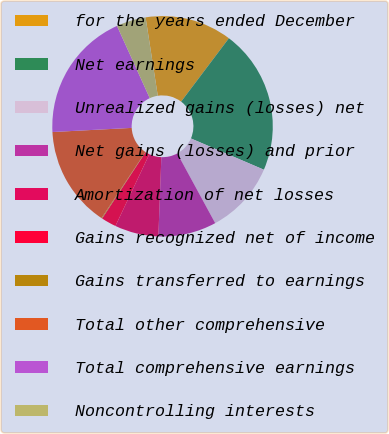Convert chart. <chart><loc_0><loc_0><loc_500><loc_500><pie_chart><fcel>for the years ended December<fcel>Net earnings<fcel>Unrealized gains (losses) net<fcel>Net gains (losses) and prior<fcel>Amortization of net losses<fcel>Gains recognized net of income<fcel>Gains transferred to earnings<fcel>Total other comprehensive<fcel>Total comprehensive earnings<fcel>Noncontrolling interests<nl><fcel>12.74%<fcel>21.16%<fcel>10.63%<fcel>8.53%<fcel>6.42%<fcel>2.21%<fcel>0.1%<fcel>14.84%<fcel>19.05%<fcel>4.32%<nl></chart> 